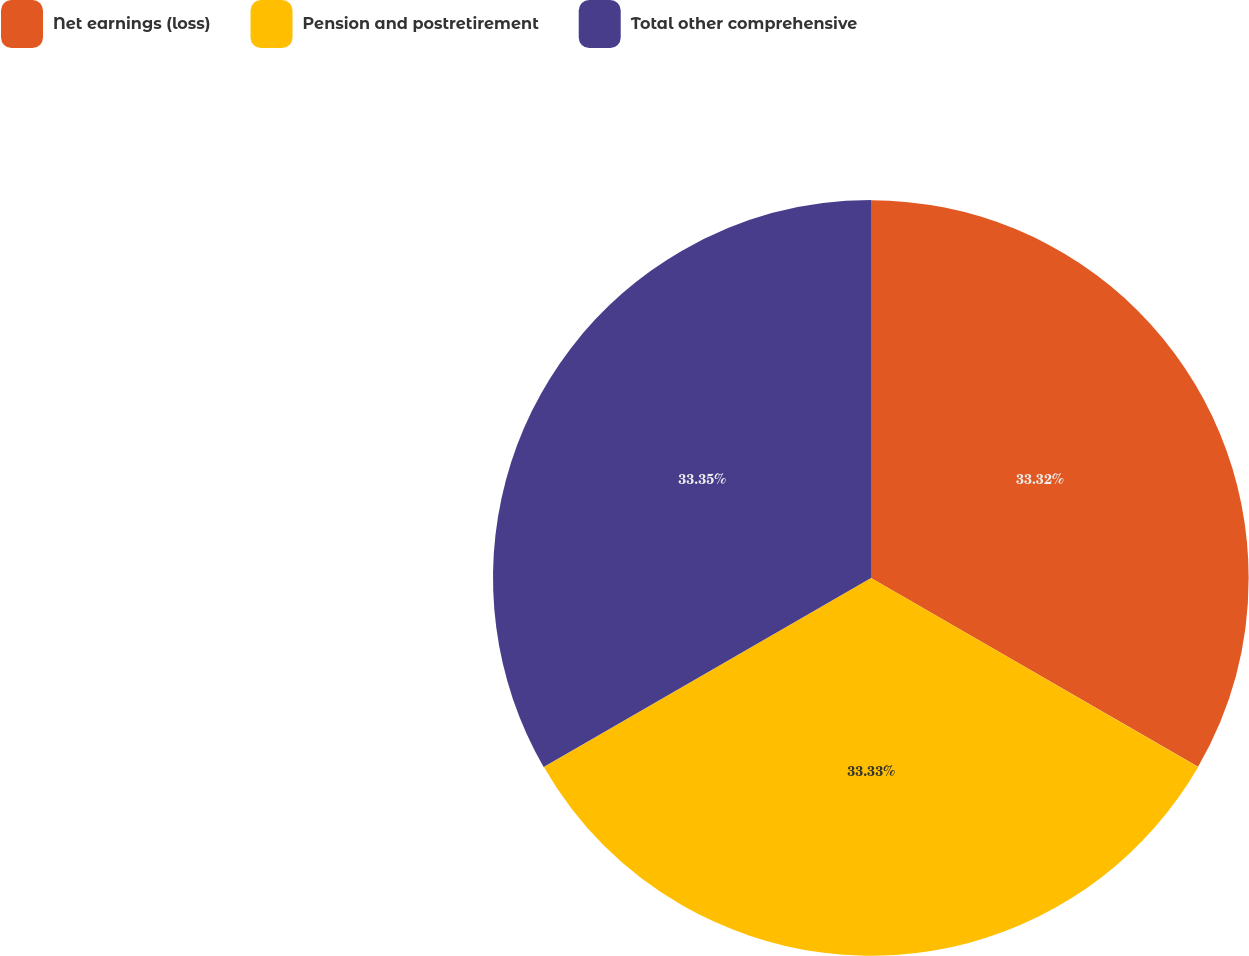<chart> <loc_0><loc_0><loc_500><loc_500><pie_chart><fcel>Net earnings (loss)<fcel>Pension and postretirement<fcel>Total other comprehensive<nl><fcel>33.32%<fcel>33.33%<fcel>33.35%<nl></chart> 